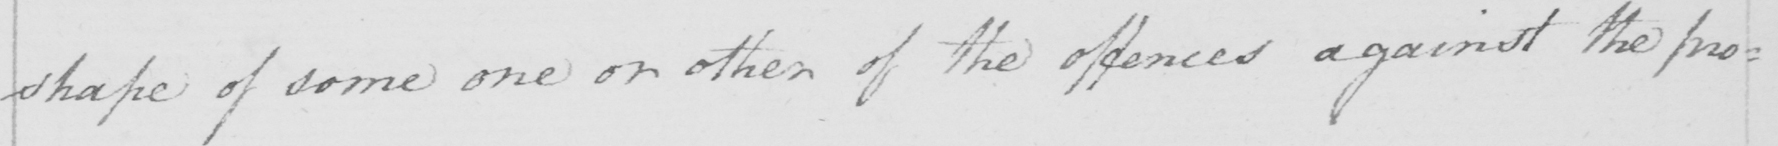Please transcribe the handwritten text in this image. shape of some one or other of the offences against the pro : 